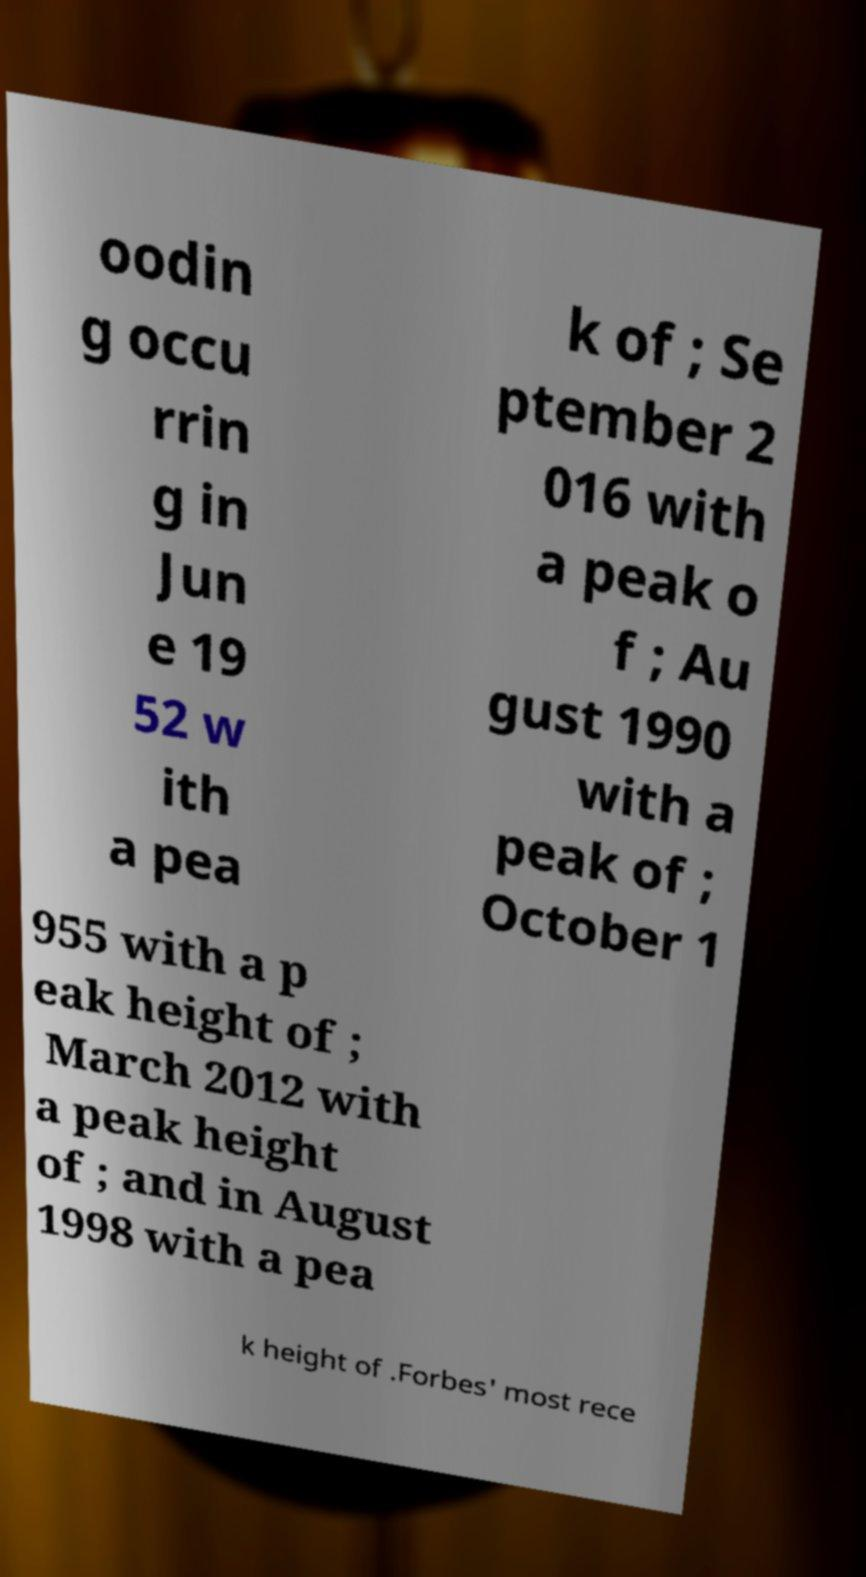Please identify and transcribe the text found in this image. oodin g occu rrin g in Jun e 19 52 w ith a pea k of ; Se ptember 2 016 with a peak o f ; Au gust 1990 with a peak of ; October 1 955 with a p eak height of ; March 2012 with a peak height of ; and in August 1998 with a pea k height of .Forbes' most rece 